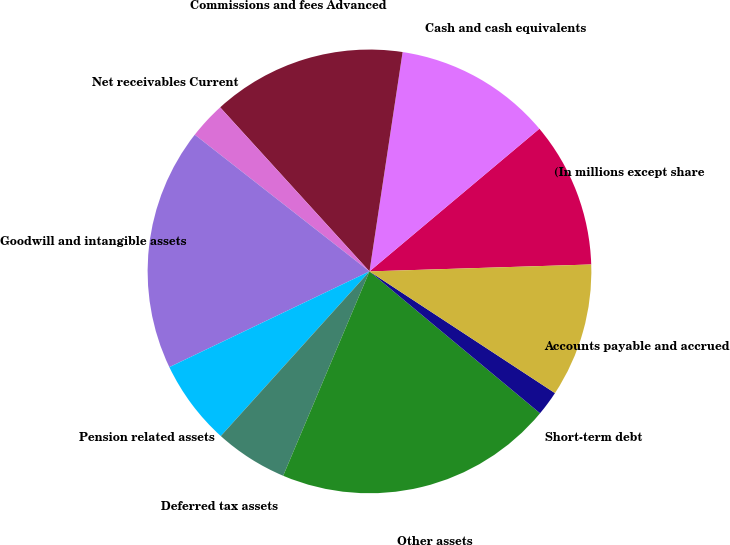<chart> <loc_0><loc_0><loc_500><loc_500><pie_chart><fcel>(In millions except share<fcel>Cash and cash equivalents<fcel>Commissions and fees Advanced<fcel>Net receivables Current<fcel>Goodwill and intangible assets<fcel>Pension related assets<fcel>Deferred tax assets<fcel>Other assets<fcel>Short-term debt<fcel>Accounts payable and accrued<nl><fcel>10.62%<fcel>11.5%<fcel>14.14%<fcel>2.68%<fcel>17.67%<fcel>6.21%<fcel>5.33%<fcel>20.32%<fcel>1.8%<fcel>9.74%<nl></chart> 